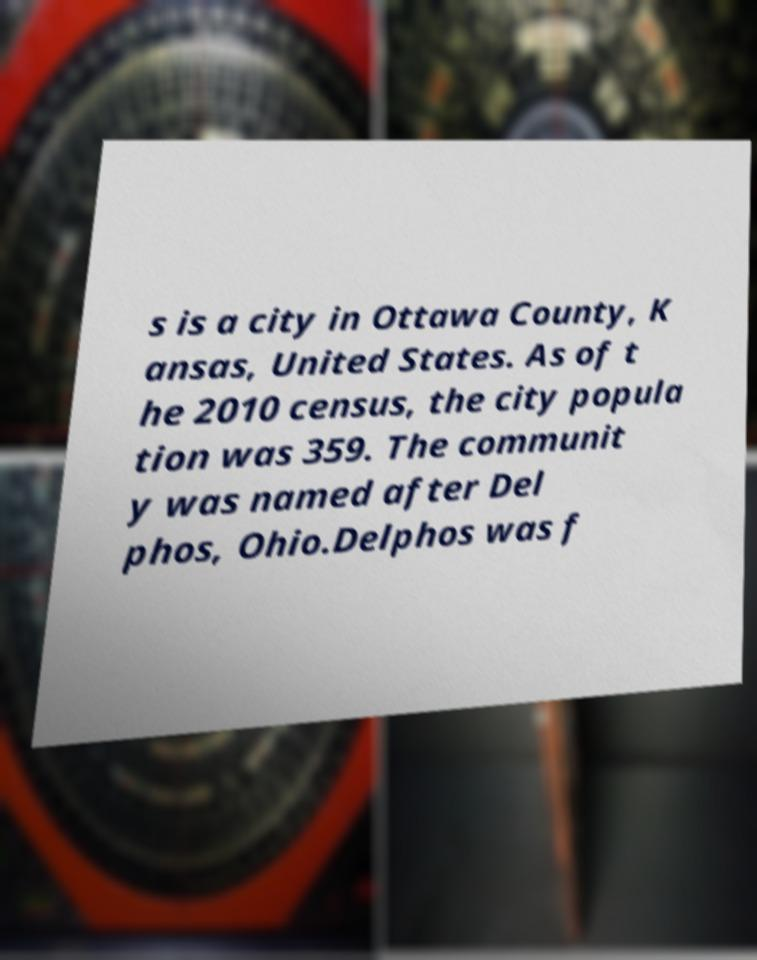Please identify and transcribe the text found in this image. s is a city in Ottawa County, K ansas, United States. As of t he 2010 census, the city popula tion was 359. The communit y was named after Del phos, Ohio.Delphos was f 